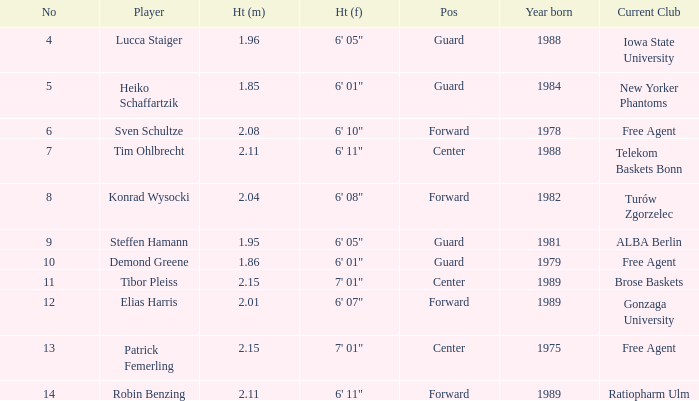Name the height of demond greene 6' 01". 